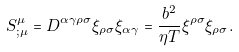<formula> <loc_0><loc_0><loc_500><loc_500>S ^ { \mu } _ { ; \mu } = D ^ { \alpha \gamma \rho \sigma } \xi _ { \rho \sigma } \xi _ { \alpha \gamma } = \frac { b ^ { 2 } } { \eta T } \xi ^ { \rho \sigma } \xi _ { \rho \sigma } .</formula> 